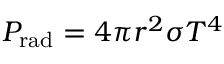<formula> <loc_0><loc_0><loc_500><loc_500>P _ { r a d } = 4 \pi r ^ { 2 } \sigma T ^ { 4 }</formula> 